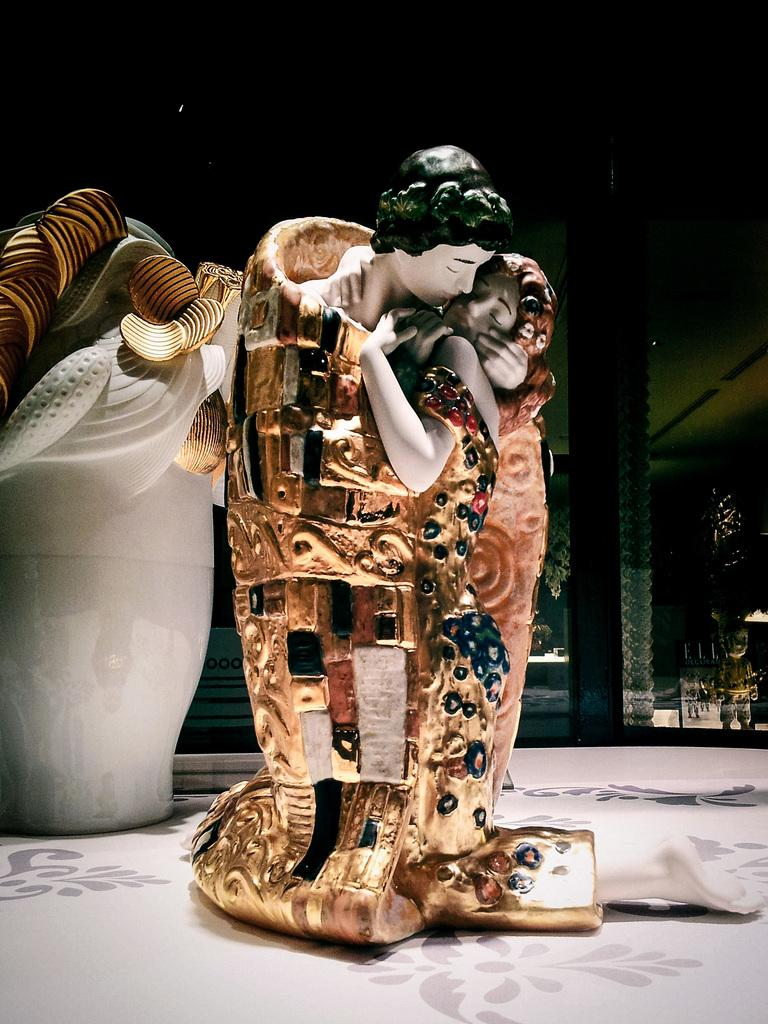How many sculptures can be seen in the image? There are two different sculptures in the image. Where are the sculptures placed in the image? The sculptures are kept on the floor. What can be seen on the right side of the image? There is a beam on the right side of the image. What time does the clock show in the image? There is no clock present in the image. How many feet can be seen in the image? There are no feet visible in the image. 